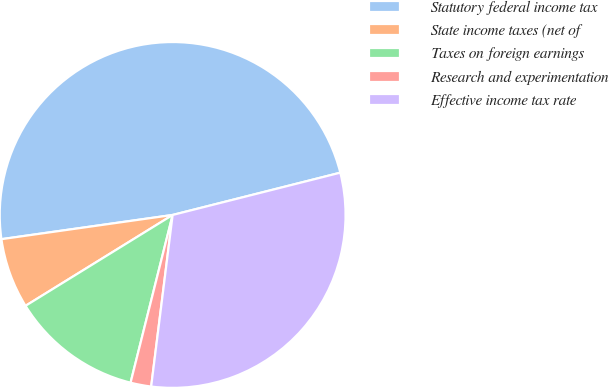<chart> <loc_0><loc_0><loc_500><loc_500><pie_chart><fcel>Statutory federal income tax<fcel>State income taxes (net of<fcel>Taxes on foreign earnings<fcel>Research and experimentation<fcel>Effective income tax rate<nl><fcel>48.3%<fcel>6.57%<fcel>12.28%<fcel>1.93%<fcel>30.91%<nl></chart> 